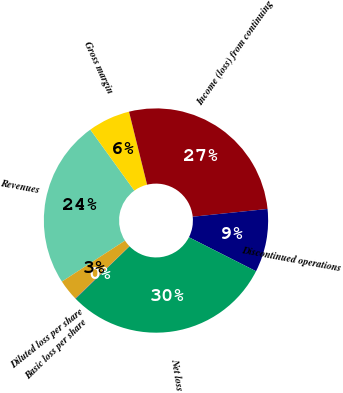<chart> <loc_0><loc_0><loc_500><loc_500><pie_chart><fcel>Revenues<fcel>Gross margin<fcel>Income (loss) from continuing<fcel>Discontinued operations<fcel>Net loss<fcel>Basic loss per share<fcel>Diluted loss per share<nl><fcel>24.2%<fcel>6.09%<fcel>27.22%<fcel>9.11%<fcel>30.24%<fcel>0.06%<fcel>3.07%<nl></chart> 